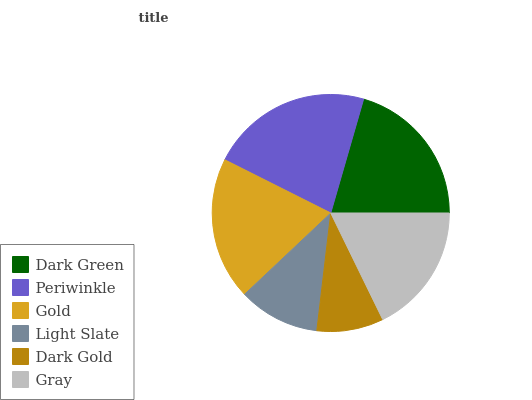Is Dark Gold the minimum?
Answer yes or no. Yes. Is Periwinkle the maximum?
Answer yes or no. Yes. Is Gold the minimum?
Answer yes or no. No. Is Gold the maximum?
Answer yes or no. No. Is Periwinkle greater than Gold?
Answer yes or no. Yes. Is Gold less than Periwinkle?
Answer yes or no. Yes. Is Gold greater than Periwinkle?
Answer yes or no. No. Is Periwinkle less than Gold?
Answer yes or no. No. Is Gold the high median?
Answer yes or no. Yes. Is Gray the low median?
Answer yes or no. Yes. Is Dark Green the high median?
Answer yes or no. No. Is Dark Gold the low median?
Answer yes or no. No. 